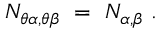Convert formula to latex. <formula><loc_0><loc_0><loc_500><loc_500>N _ { \theta \alpha , \theta \beta } = N _ { \alpha , \beta } .</formula> 